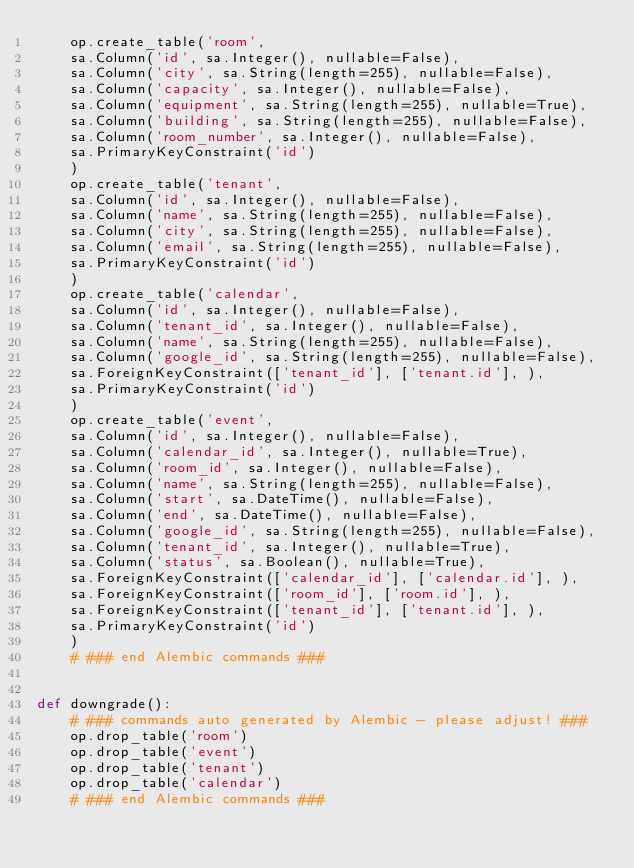<code> <loc_0><loc_0><loc_500><loc_500><_Python_>    op.create_table('room',
    sa.Column('id', sa.Integer(), nullable=False),
    sa.Column('city', sa.String(length=255), nullable=False),
    sa.Column('capacity', sa.Integer(), nullable=False),
    sa.Column('equipment', sa.String(length=255), nullable=True),
    sa.Column('building', sa.String(length=255), nullable=False),
    sa.Column('room_number', sa.Integer(), nullable=False),
    sa.PrimaryKeyConstraint('id')
    )
    op.create_table('tenant',
    sa.Column('id', sa.Integer(), nullable=False),
    sa.Column('name', sa.String(length=255), nullable=False),
    sa.Column('city', sa.String(length=255), nullable=False),
    sa.Column('email', sa.String(length=255), nullable=False),
    sa.PrimaryKeyConstraint('id')
    )
    op.create_table('calendar',
    sa.Column('id', sa.Integer(), nullable=False),
    sa.Column('tenant_id', sa.Integer(), nullable=False),
    sa.Column('name', sa.String(length=255), nullable=False),
    sa.Column('google_id', sa.String(length=255), nullable=False),
    sa.ForeignKeyConstraint(['tenant_id'], ['tenant.id'], ),
    sa.PrimaryKeyConstraint('id')
    )
    op.create_table('event',
    sa.Column('id', sa.Integer(), nullable=False),
    sa.Column('calendar_id', sa.Integer(), nullable=True),
    sa.Column('room_id', sa.Integer(), nullable=False),
    sa.Column('name', sa.String(length=255), nullable=False),
    sa.Column('start', sa.DateTime(), nullable=False),
    sa.Column('end', sa.DateTime(), nullable=False),
    sa.Column('google_id', sa.String(length=255), nullable=False),
    sa.Column('tenant_id', sa.Integer(), nullable=True),
    sa.Column('status', sa.Boolean(), nullable=True),
    sa.ForeignKeyConstraint(['calendar_id'], ['calendar.id'], ),
    sa.ForeignKeyConstraint(['room_id'], ['room.id'], ),
    sa.ForeignKeyConstraint(['tenant_id'], ['tenant.id'], ),
    sa.PrimaryKeyConstraint('id')
    )
    # ### end Alembic commands ###


def downgrade():
    # ### commands auto generated by Alembic - please adjust! ###
    op.drop_table('room')
    op.drop_table('event')
    op.drop_table('tenant')
    op.drop_table('calendar')
    # ### end Alembic commands ###
</code> 